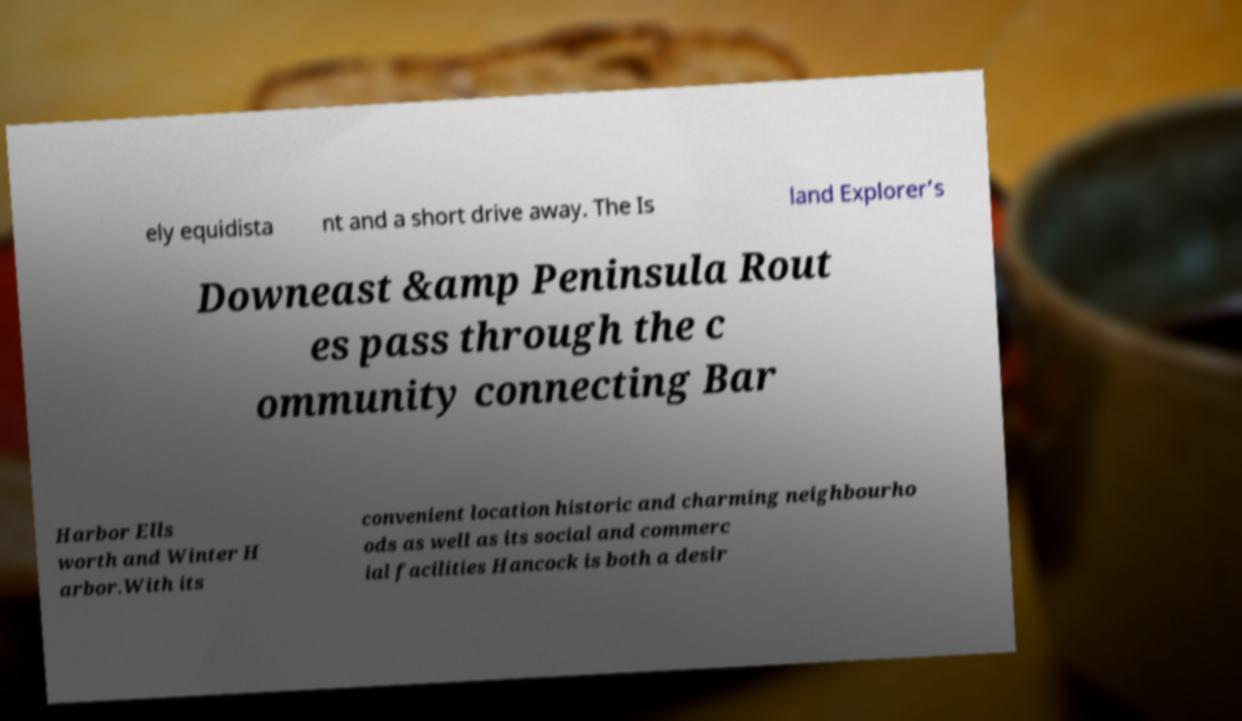Could you extract and type out the text from this image? ely equidista nt and a short drive away. The Is land Explorer’s Downeast &amp Peninsula Rout es pass through the c ommunity connecting Bar Harbor Ells worth and Winter H arbor.With its convenient location historic and charming neighbourho ods as well as its social and commerc ial facilities Hancock is both a desir 